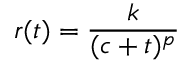Convert formula to latex. <formula><loc_0><loc_0><loc_500><loc_500>r ( t ) = \frac { k } { ( c + t ) ^ { p } }</formula> 